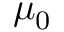<formula> <loc_0><loc_0><loc_500><loc_500>\mu _ { 0 }</formula> 